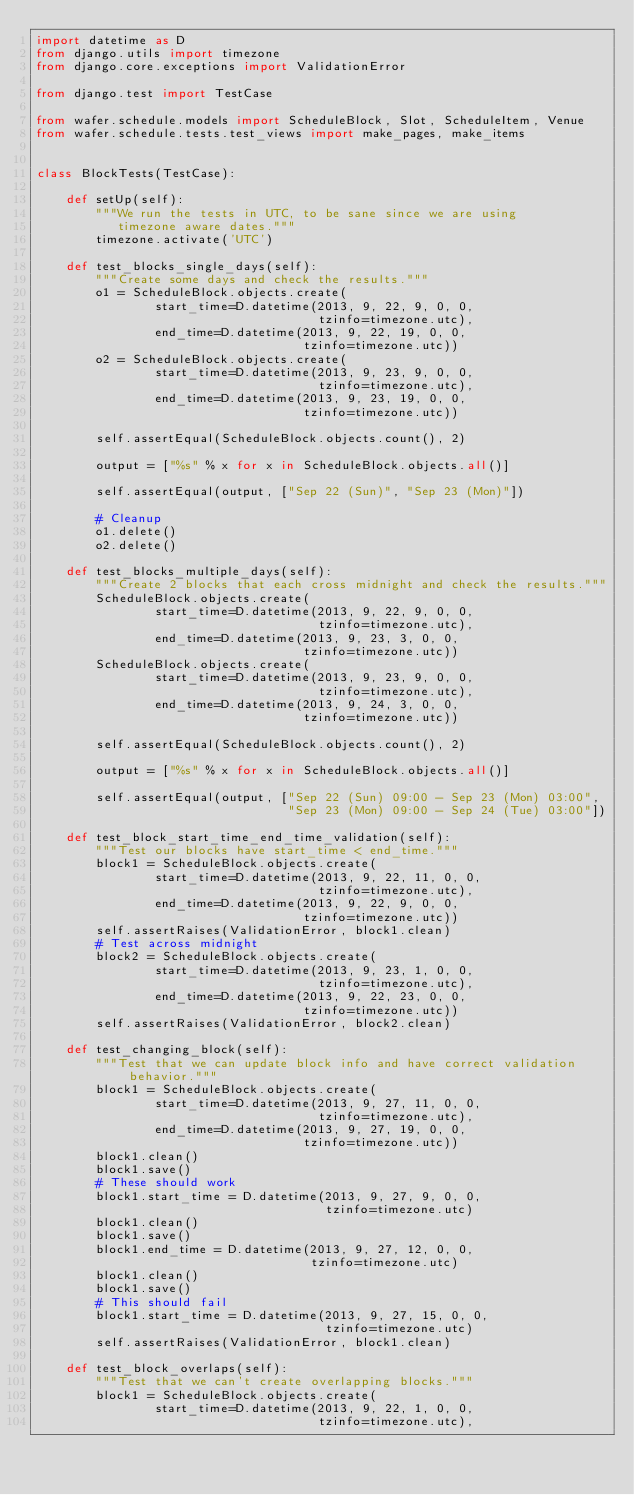Convert code to text. <code><loc_0><loc_0><loc_500><loc_500><_Python_>import datetime as D
from django.utils import timezone
from django.core.exceptions import ValidationError

from django.test import TestCase

from wafer.schedule.models import ScheduleBlock, Slot, ScheduleItem, Venue
from wafer.schedule.tests.test_views import make_pages, make_items


class BlockTests(TestCase):

    def setUp(self):
        """We run the tests in UTC, to be sane since we are using
           timezone aware dates."""
        timezone.activate('UTC')

    def test_blocks_single_days(self):
        """Create some days and check the results."""
        o1 = ScheduleBlock.objects.create(
                start_time=D.datetime(2013, 9, 22, 9, 0, 0,
                                      tzinfo=timezone.utc),
                end_time=D.datetime(2013, 9, 22, 19, 0, 0,
                                    tzinfo=timezone.utc))
        o2 = ScheduleBlock.objects.create(
                start_time=D.datetime(2013, 9, 23, 9, 0, 0,
                                      tzinfo=timezone.utc),
                end_time=D.datetime(2013, 9, 23, 19, 0, 0,
                                    tzinfo=timezone.utc))

        self.assertEqual(ScheduleBlock.objects.count(), 2)

        output = ["%s" % x for x in ScheduleBlock.objects.all()]

        self.assertEqual(output, ["Sep 22 (Sun)", "Sep 23 (Mon)"])

        # Cleanup
        o1.delete()
        o2.delete()

    def test_blocks_multiple_days(self):
        """Create 2 blocks that each cross midnight and check the results."""
        ScheduleBlock.objects.create(
                start_time=D.datetime(2013, 9, 22, 9, 0, 0,
                                      tzinfo=timezone.utc),
                end_time=D.datetime(2013, 9, 23, 3, 0, 0,
                                    tzinfo=timezone.utc))
        ScheduleBlock.objects.create(
                start_time=D.datetime(2013, 9, 23, 9, 0, 0,
                                      tzinfo=timezone.utc),
                end_time=D.datetime(2013, 9, 24, 3, 0, 0,
                                    tzinfo=timezone.utc))

        self.assertEqual(ScheduleBlock.objects.count(), 2)

        output = ["%s" % x for x in ScheduleBlock.objects.all()]

        self.assertEqual(output, ["Sep 22 (Sun) 09:00 - Sep 23 (Mon) 03:00",
                                  "Sep 23 (Mon) 09:00 - Sep 24 (Tue) 03:00"])

    def test_block_start_time_end_time_validation(self):
        """Test our blocks have start_time < end_time."""
        block1 = ScheduleBlock.objects.create(
                start_time=D.datetime(2013, 9, 22, 11, 0, 0,
                                      tzinfo=timezone.utc),
                end_time=D.datetime(2013, 9, 22, 9, 0, 0,
                                    tzinfo=timezone.utc))
        self.assertRaises(ValidationError, block1.clean)
        # Test across midnight
        block2 = ScheduleBlock.objects.create(
                start_time=D.datetime(2013, 9, 23, 1, 0, 0,
                                      tzinfo=timezone.utc),
                end_time=D.datetime(2013, 9, 22, 23, 0, 0,
                                    tzinfo=timezone.utc))
        self.assertRaises(ValidationError, block2.clean)

    def test_changing_block(self):
        """Test that we can update block info and have correct validation behavior."""
        block1 = ScheduleBlock.objects.create(
                start_time=D.datetime(2013, 9, 27, 11, 0, 0,
                                      tzinfo=timezone.utc),
                end_time=D.datetime(2013, 9, 27, 19, 0, 0,
                                    tzinfo=timezone.utc))
        block1.clean()
        block1.save()
        # These should work
        block1.start_time = D.datetime(2013, 9, 27, 9, 0, 0,
                                       tzinfo=timezone.utc)
        block1.clean()
        block1.save()
        block1.end_time = D.datetime(2013, 9, 27, 12, 0, 0,
                                     tzinfo=timezone.utc)
        block1.clean()
        block1.save()
        # This should fail
        block1.start_time = D.datetime(2013, 9, 27, 15, 0, 0,
                                       tzinfo=timezone.utc)
        self.assertRaises(ValidationError, block1.clean)

    def test_block_overlaps(self):
        """Test that we can't create overlapping blocks."""
        block1 = ScheduleBlock.objects.create(
                start_time=D.datetime(2013, 9, 22, 1, 0, 0,
                                      tzinfo=timezone.utc),</code> 